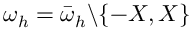Convert formula to latex. <formula><loc_0><loc_0><loc_500><loc_500>\omega _ { h } = \bar { \omega } _ { h } \ \{ - X , X \}</formula> 